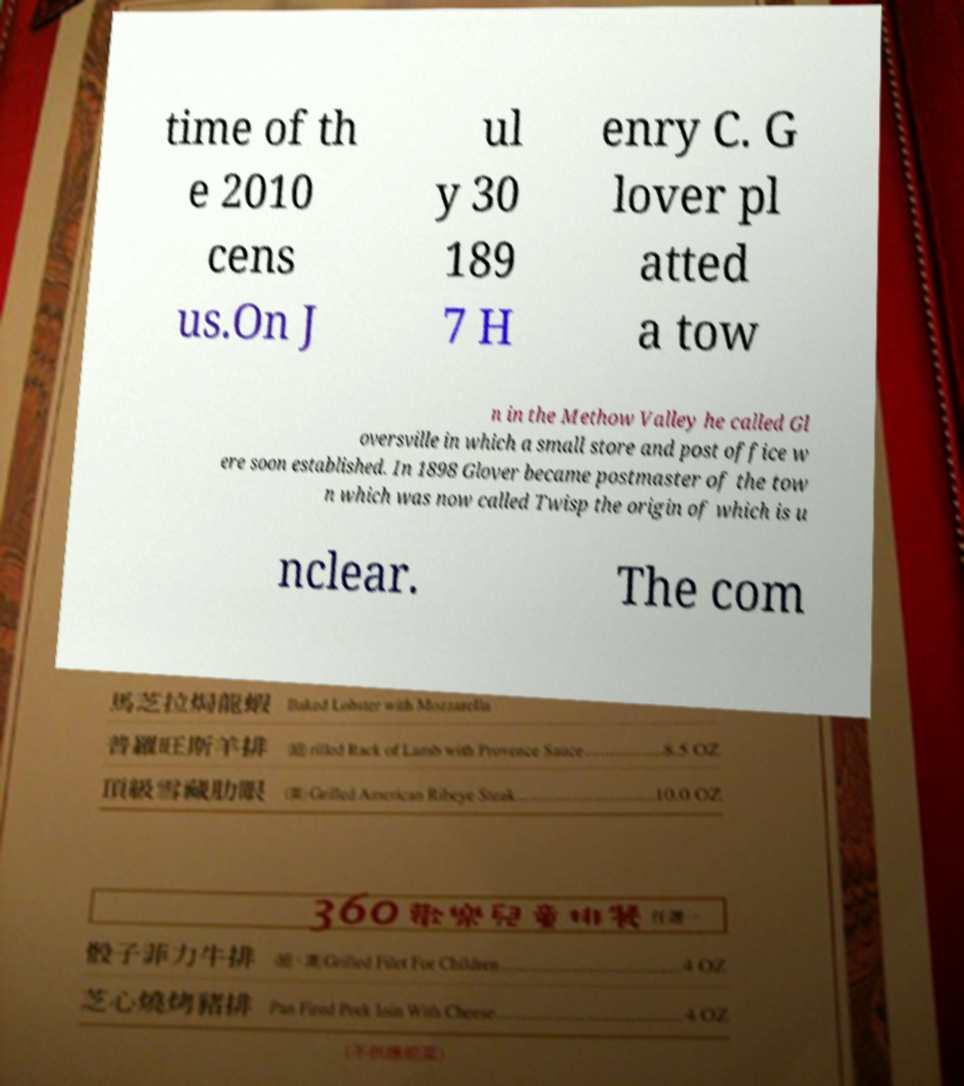Can you accurately transcribe the text from the provided image for me? time of th e 2010 cens us.On J ul y 30 189 7 H enry C. G lover pl atted a tow n in the Methow Valley he called Gl oversville in which a small store and post office w ere soon established. In 1898 Glover became postmaster of the tow n which was now called Twisp the origin of which is u nclear. The com 